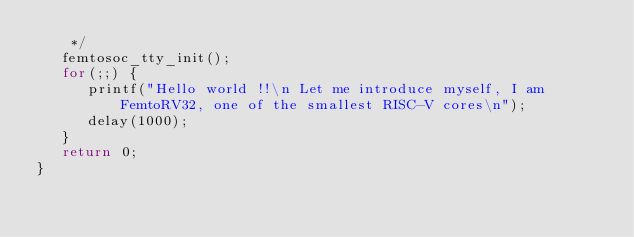Convert code to text. <code><loc_0><loc_0><loc_500><loc_500><_C_>    */
   femtosoc_tty_init();
   for(;;) {
      printf("Hello world !!\n Let me introduce myself, I am FemtoRV32, one of the smallest RISC-V cores\n");
      delay(1000);
   }
   return 0;
}

</code> 